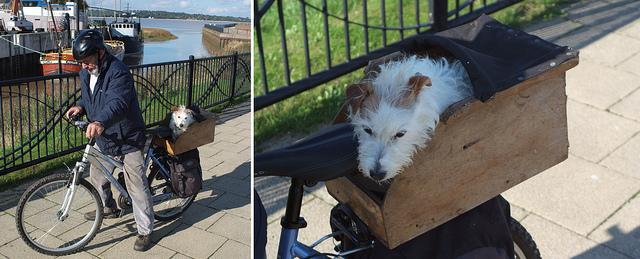Who placed this animal in the box? owner 